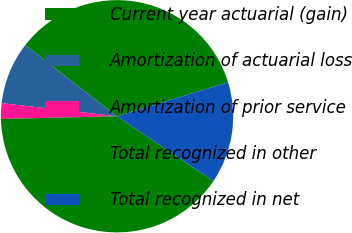<chart> <loc_0><loc_0><loc_500><loc_500><pie_chart><fcel>Current year actuarial (gain)<fcel>Amortization of actuarial loss<fcel>Amortization of prior service<fcel>Total recognized in other<fcel>Total recognized in net<nl><fcel>34.78%<fcel>8.7%<fcel>2.17%<fcel>40.22%<fcel>14.13%<nl></chart> 